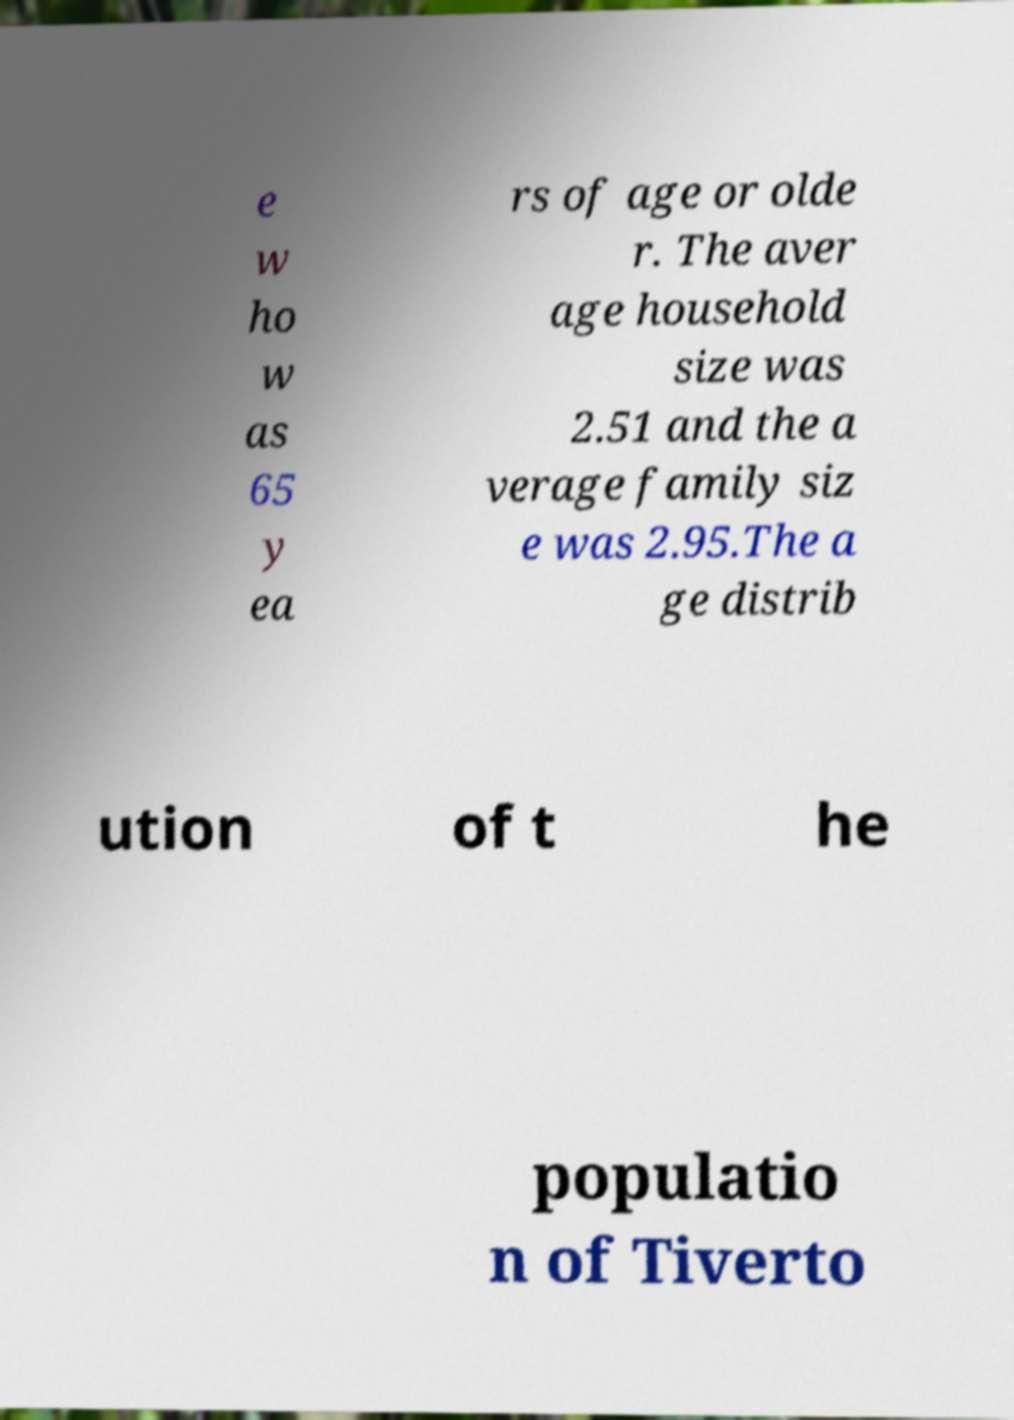Please identify and transcribe the text found in this image. e w ho w as 65 y ea rs of age or olde r. The aver age household size was 2.51 and the a verage family siz e was 2.95.The a ge distrib ution of t he populatio n of Tiverto 